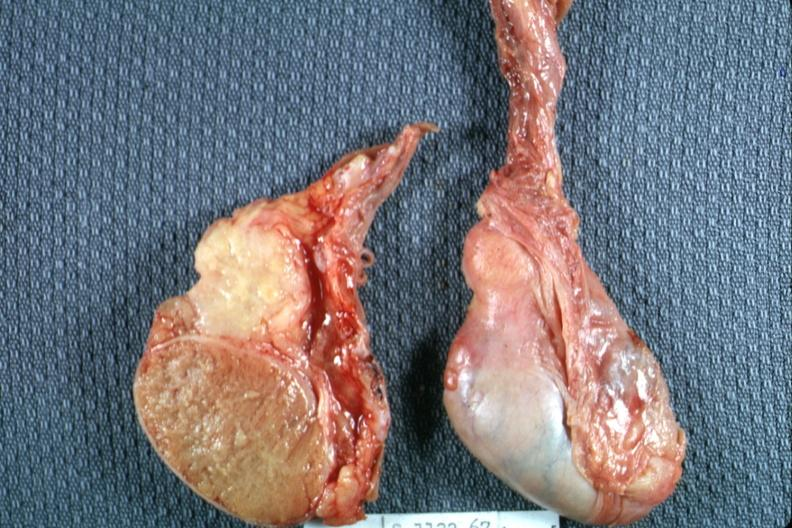s tuberculosis present?
Answer the question using a single word or phrase. Yes 